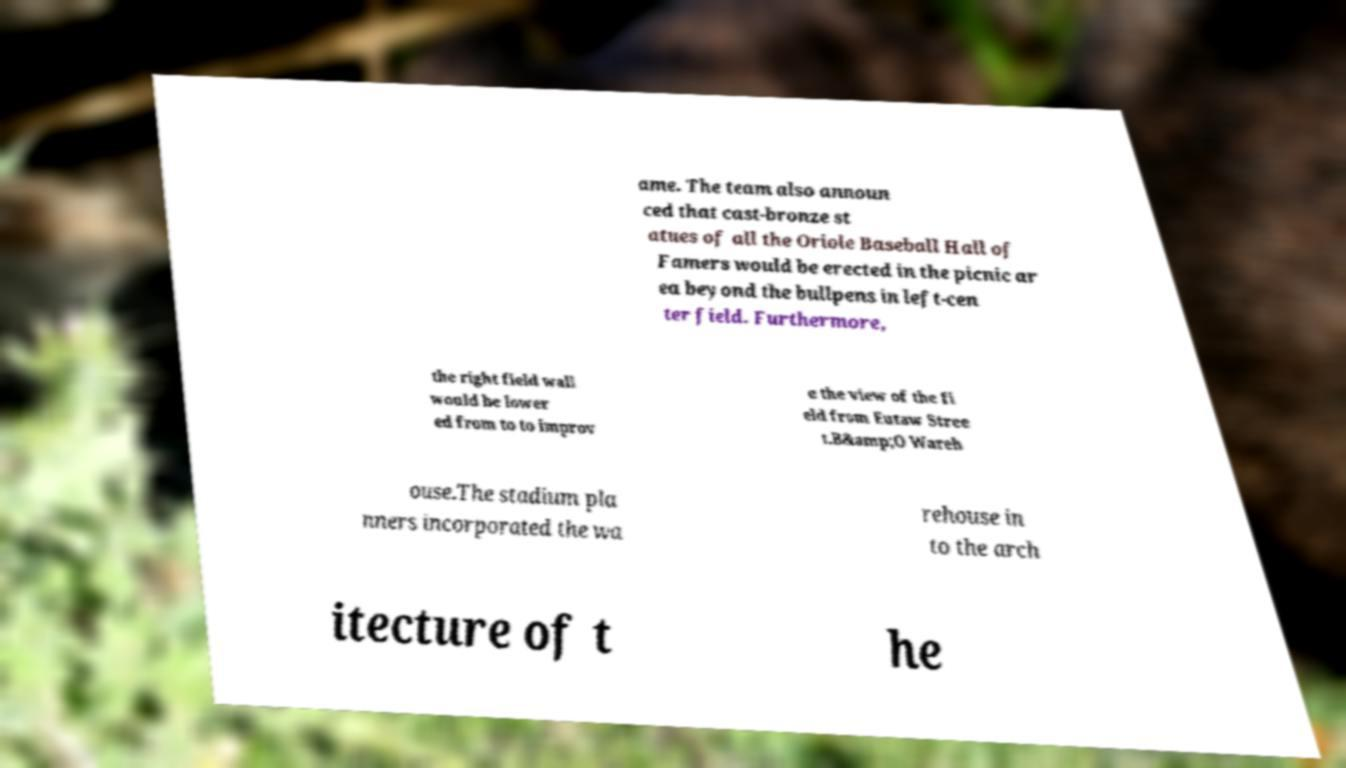Could you extract and type out the text from this image? ame. The team also announ ced that cast-bronze st atues of all the Oriole Baseball Hall of Famers would be erected in the picnic ar ea beyond the bullpens in left-cen ter field. Furthermore, the right field wall would be lower ed from to to improv e the view of the fi eld from Eutaw Stree t.B&amp;O Wareh ouse.The stadium pla nners incorporated the wa rehouse in to the arch itecture of t he 